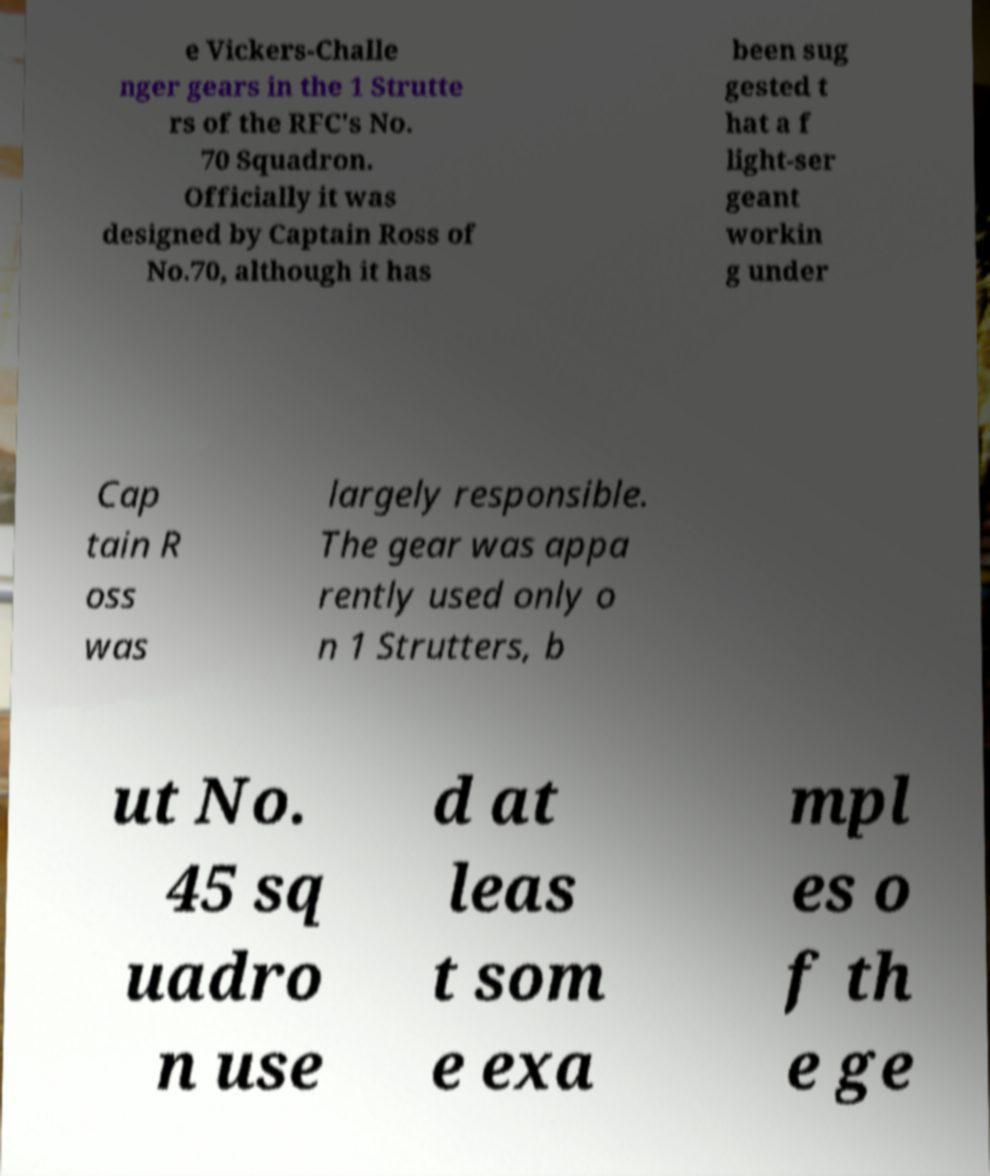What messages or text are displayed in this image? I need them in a readable, typed format. e Vickers-Challe nger gears in the 1 Strutte rs of the RFC's No. 70 Squadron. Officially it was designed by Captain Ross of No.70, although it has been sug gested t hat a f light-ser geant workin g under Cap tain R oss was largely responsible. The gear was appa rently used only o n 1 Strutters, b ut No. 45 sq uadro n use d at leas t som e exa mpl es o f th e ge 